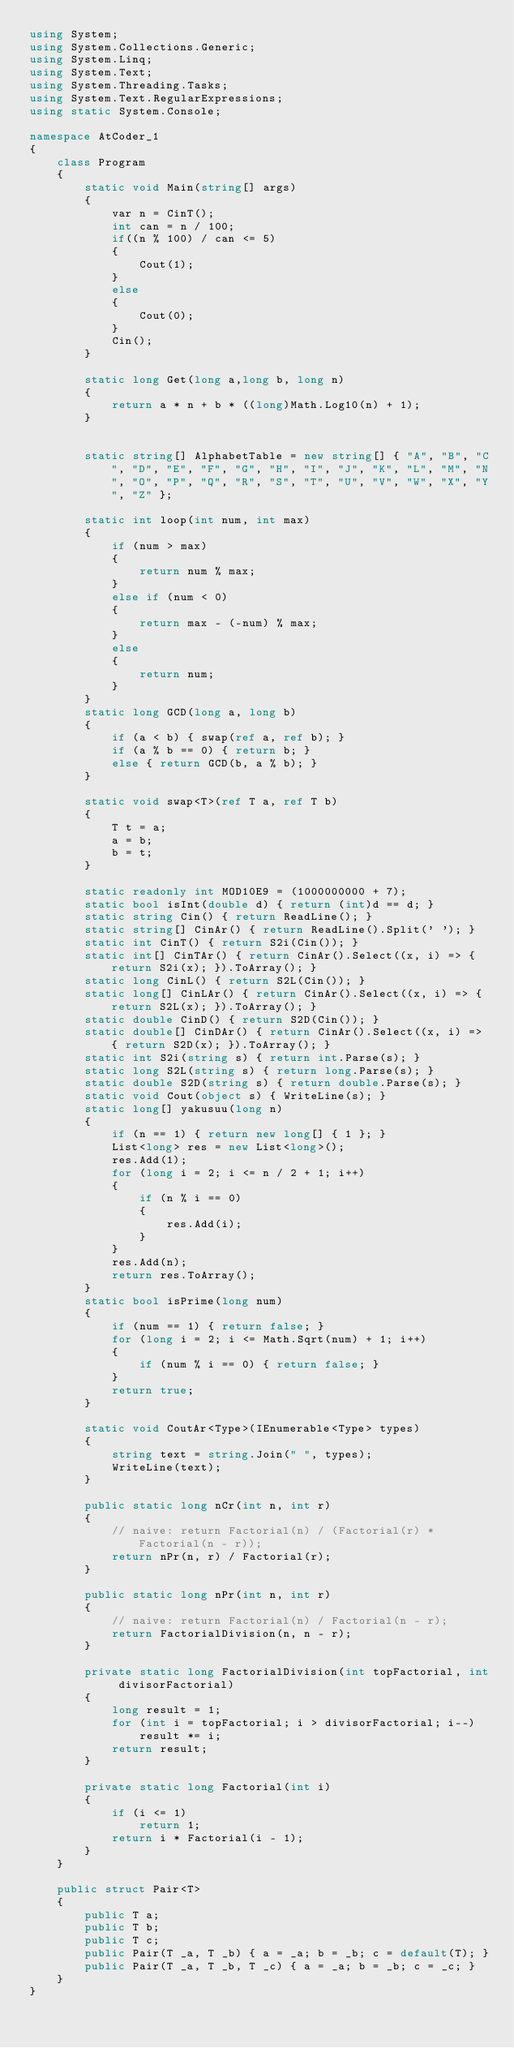<code> <loc_0><loc_0><loc_500><loc_500><_C#_>using System;
using System.Collections.Generic;
using System.Linq;
using System.Text;
using System.Threading.Tasks;
using System.Text.RegularExpressions;
using static System.Console;

namespace AtCoder_1
{
    class Program
    {
        static void Main(string[] args)
        {
            var n = CinT();
            int can = n / 100;
            if((n % 100) / can <= 5)
            {
                Cout(1);
            }
            else
            {
                Cout(0);
            }
            Cin();
        }

        static long Get(long a,long b, long n)
        {
            return a * n + b * ((long)Math.Log10(n) + 1);
        }


        static string[] AlphabetTable = new string[] { "A", "B", "C", "D", "E", "F", "G", "H", "I", "J", "K", "L", "M", "N", "O", "P", "Q", "R", "S", "T", "U", "V", "W", "X", "Y", "Z" };

        static int loop(int num, int max)
        {
            if (num > max)
            {
                return num % max;
            }
            else if (num < 0)
            {
                return max - (-num) % max;
            }
            else
            {
                return num;
            }
        }
        static long GCD(long a, long b)
        {
            if (a < b) { swap(ref a, ref b); }
            if (a % b == 0) { return b; }
            else { return GCD(b, a % b); }
        }

        static void swap<T>(ref T a, ref T b)
        {
            T t = a;
            a = b;
            b = t;
        }

        static readonly int MOD10E9 = (1000000000 + 7);
        static bool isInt(double d) { return (int)d == d; }
        static string Cin() { return ReadLine(); }
        static string[] CinAr() { return ReadLine().Split(' '); }
        static int CinT() { return S2i(Cin()); }
        static int[] CinTAr() { return CinAr().Select((x, i) => { return S2i(x); }).ToArray(); }
        static long CinL() { return S2L(Cin()); }
        static long[] CinLAr() { return CinAr().Select((x, i) => { return S2L(x); }).ToArray(); }
        static double CinD() { return S2D(Cin()); }
        static double[] CinDAr() { return CinAr().Select((x, i) => { return S2D(x); }).ToArray(); }
        static int S2i(string s) { return int.Parse(s); }
        static long S2L(string s) { return long.Parse(s); }
        static double S2D(string s) { return double.Parse(s); }
        static void Cout(object s) { WriteLine(s); }
        static long[] yakusuu(long n)
        {
            if (n == 1) { return new long[] { 1 }; }
            List<long> res = new List<long>();
            res.Add(1);
            for (long i = 2; i <= n / 2 + 1; i++)
            {
                if (n % i == 0)
                {
                    res.Add(i);
                }
            }
            res.Add(n);
            return res.ToArray();
        }
        static bool isPrime(long num)
        {
            if (num == 1) { return false; }
            for (long i = 2; i <= Math.Sqrt(num) + 1; i++)
            {
                if (num % i == 0) { return false; }
            }
            return true;
        }

        static void CoutAr<Type>(IEnumerable<Type> types)
        {
            string text = string.Join(" ", types);
            WriteLine(text);
        }

        public static long nCr(int n, int r)
        {
            // naive: return Factorial(n) / (Factorial(r) * Factorial(n - r));
            return nPr(n, r) / Factorial(r);
        }

        public static long nPr(int n, int r)
        {
            // naive: return Factorial(n) / Factorial(n - r);
            return FactorialDivision(n, n - r);
        }

        private static long FactorialDivision(int topFactorial, int divisorFactorial)
        {
            long result = 1;
            for (int i = topFactorial; i > divisorFactorial; i--)
                result *= i;
            return result;
        }

        private static long Factorial(int i)
        {
            if (i <= 1)
                return 1;
            return i * Factorial(i - 1);
        }
    }

    public struct Pair<T>
    {
        public T a;
        public T b;
        public T c;
        public Pair(T _a, T _b) { a = _a; b = _b; c = default(T); }
        public Pair(T _a, T _b, T _c) { a = _a; b = _b; c = _c; }
    }
}
</code> 